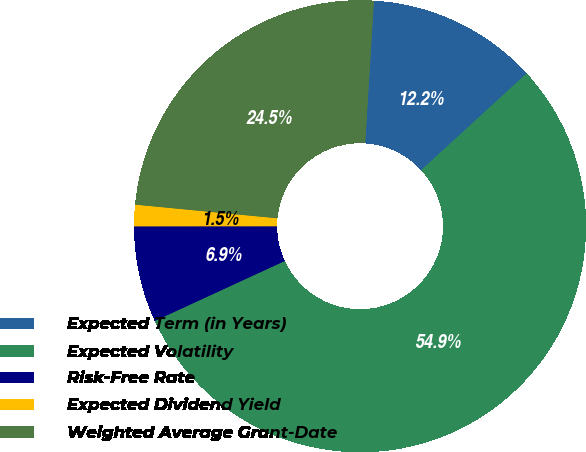Convert chart to OTSL. <chart><loc_0><loc_0><loc_500><loc_500><pie_chart><fcel>Expected Term (in Years)<fcel>Expected Volatility<fcel>Risk-Free Rate<fcel>Expected Dividend Yield<fcel>Weighted Average Grant-Date<nl><fcel>12.21%<fcel>54.93%<fcel>6.87%<fcel>1.53%<fcel>24.45%<nl></chart> 